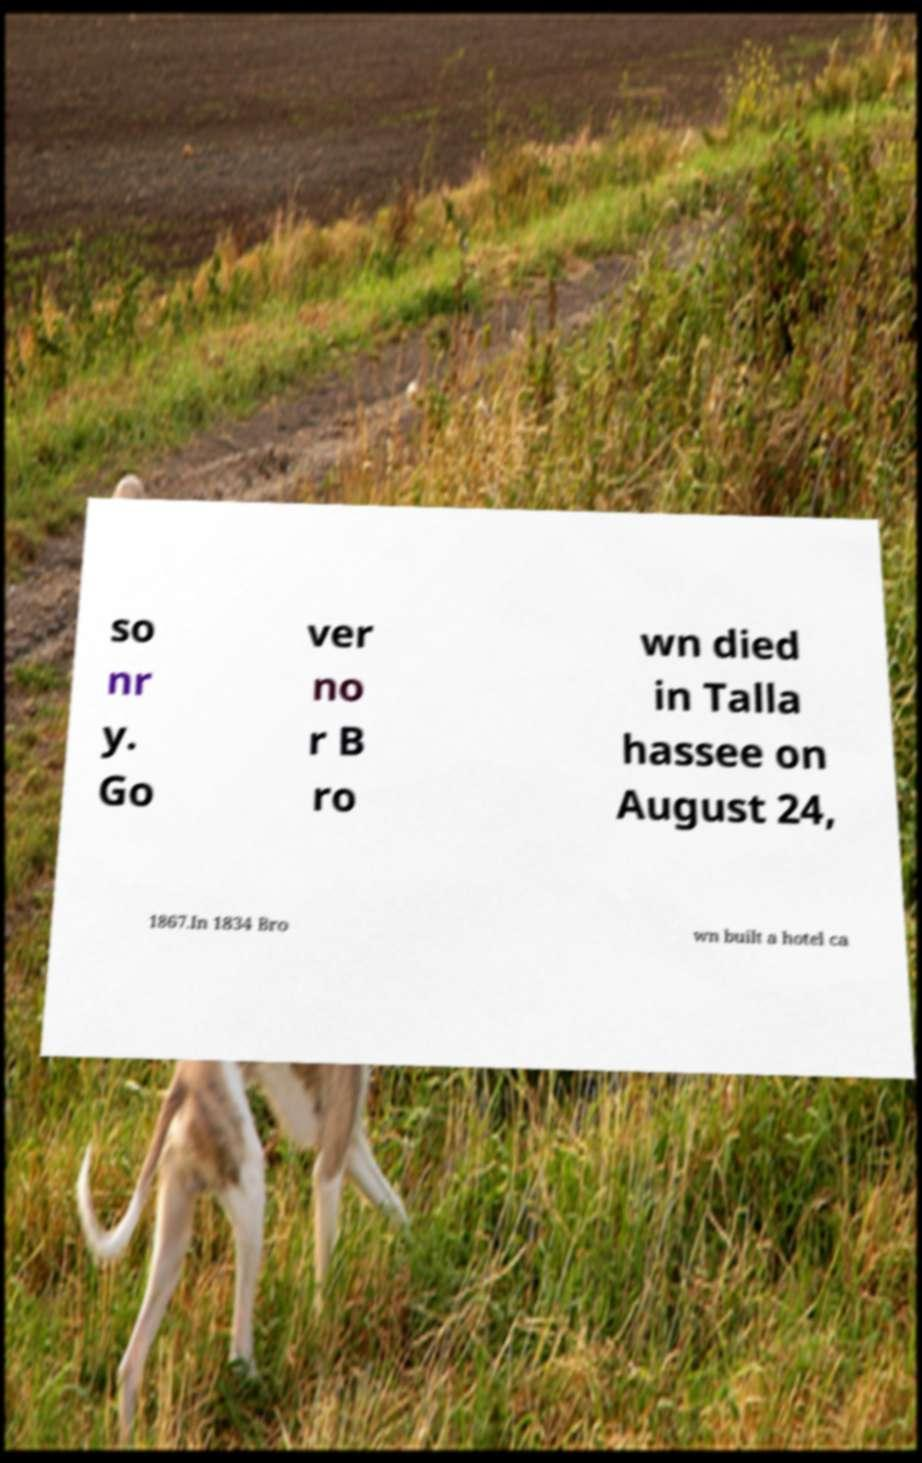Please identify and transcribe the text found in this image. so nr y. Go ver no r B ro wn died in Talla hassee on August 24, 1867.In 1834 Bro wn built a hotel ca 